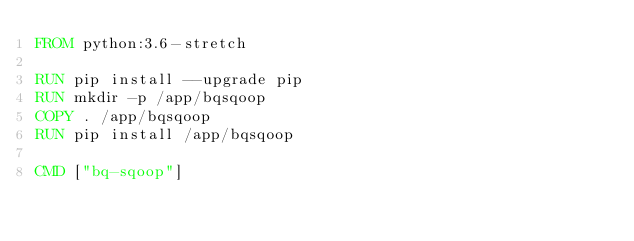<code> <loc_0><loc_0><loc_500><loc_500><_Dockerfile_>FROM python:3.6-stretch

RUN pip install --upgrade pip
RUN mkdir -p /app/bqsqoop
COPY . /app/bqsqoop
RUN pip install /app/bqsqoop

CMD ["bq-sqoop"]</code> 